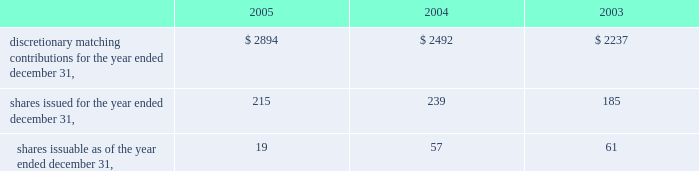Fund .
Employees have the ability to transfer funds from the company stock fund as they choose .
The company declared matching contributions to the vertex 401 ( k ) plan as follows ( in thousands ) : q .
Related party transactions as of december 31 , 2005 and 2004 , the company had an interest-free loan outstanding to an officer in the amount of $ 36000 and $ 97000 , respectively , which was initially advanced in april 2002 .
The loan balance is included in other assets on the consolidated balance sheets .
In 2001 , the company entered into a four year consulting agreement with a director of the company for the provision of part-time consulting services over a period of four years , at the rate of $ 80000 per year commencing in january 2002 and terminating in january 2006 .
Contingencies the company has certain contingent liabilities that arise in the ordinary course of its business activities .
The company accrues contingent liabilities when it is probable that future expenditures will be made and such expenditures can be reasonably estimated .
On december 17 , 2003 , a purported class action , marguerite sacchetti v .
James c .
Blair et al. , was filed in the superior court of the state of california , county of san diego , naming as defendants all of the directors of aurora who approved the merger of aurora and vertex , which closed in july 2001 .
The plaintiffs claim that aurora's directors breached their fiduciary duty to aurora by , among other things , negligently conducting a due diligence examination of vertex by failing to discover alleged problems with vx-745 , a vertex drug candidate that was the subject of a development program which was terminated by vertex in september 2001 .
Vertex has certain indemnity obligations to aurora's directors under the terms of the merger agreement between vertex and aurora , which could result in vertex liability for attorney's fees and costs in connection with this action , as well as for any ultimate judgment that might be awarded .
There is an outstanding directors' and officers' liability policy which may cover a significant portion of any such liability .
The defendants are vigorously defending this suit .
The company believes this suit will be settled without any significant liability to vertex or the former aurora directors .
Guarantees as permitted under massachusetts law , vertex's articles of organization and bylaws provide that the company will indemnify certain of its officers and directors for certain claims asserted against them in connection with their service as an officer or director .
The maximum potential amount of future payments that the company could be required to make under these indemnification provisions is unlimited .
However , the company has purchased certain directors' and officers' liability insurance policies that reduce its monetary exposure and enable it to recover a portion of any future amounts paid .
The company believes the estimated fair value of these indemnification arrangements is minimal .
Discretionary matching contributions for the year ended december 31 , $ 2894 $ 2492 $ 2237 .

What was the change in the 2 discretionary matching contributions from 2004 to 2005 in millions? 
Computations: (2894 - 2492)
Answer: 402.0. 